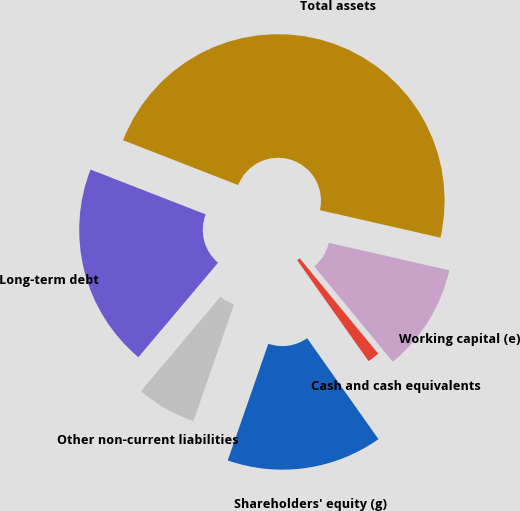Convert chart. <chart><loc_0><loc_0><loc_500><loc_500><pie_chart><fcel>Cash and cash equivalents<fcel>Working capital (e)<fcel>Total assets<fcel>Long-term debt<fcel>Other non-current liabilities<fcel>Shareholders' equity (g)<nl><fcel>1.17%<fcel>10.47%<fcel>47.67%<fcel>19.77%<fcel>5.82%<fcel>15.12%<nl></chart> 